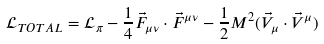Convert formula to latex. <formula><loc_0><loc_0><loc_500><loc_500>\mathcal { L } _ { T O T A L } = \mathcal { L } _ { \pi } - \frac { 1 } { 4 } \vec { F } _ { \mu \nu } \cdot \vec { F } ^ { \mu \nu } - \frac { 1 } { 2 } M ^ { 2 } ( \vec { V } _ { \mu } \cdot \vec { V } ^ { \mu } )</formula> 